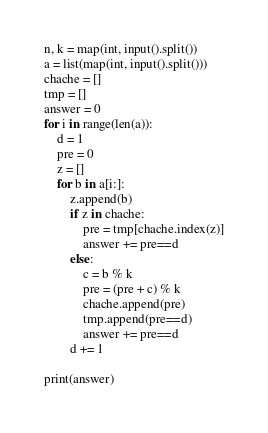Convert code to text. <code><loc_0><loc_0><loc_500><loc_500><_Python_>n, k = map(int, input().split())
a = list(map(int, input().split()))
chache = []
tmp = []
answer = 0
for i in range(len(a)):
    d = 1
    pre = 0
    z = []
    for b in a[i:]:
        z.append(b)
        if z in chache:
            pre = tmp[chache.index(z)]
            answer += pre==d
        else:
            c = b % k
            pre = (pre + c) % k
            chache.append(pre)
            tmp.append(pre==d)
            answer += pre==d
        d += 1

print(answer)</code> 